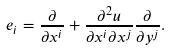Convert formula to latex. <formula><loc_0><loc_0><loc_500><loc_500>e _ { i } = \frac { \partial } { \partial x ^ { i } } + \frac { \partial ^ { 2 } u } { \partial x ^ { i } \partial x ^ { j } } \frac { \partial } { \partial y ^ { j } } .</formula> 